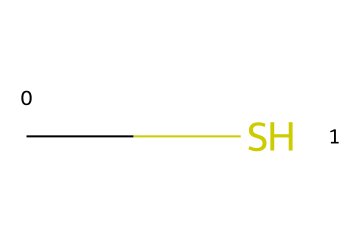What is the name of this compound? The structure represented by the SMILES designation "CS" corresponds to methylmercaptan, which is a sulfur compound. The 'C' represents a carbon atom, and the 'S' represents a sulfur atom, indicating the chemical name based on common nomenclature.
Answer: methylmercaptan How many atoms are present in this molecule? The SMILES notation "CS" indicates that there are two atoms in total: one carbon (C) and one sulfur (S) atom. The count can be determined by identifying each character in the SMILES string.
Answer: 2 What type of bond is present between the carbon and sulfur in this compound? In the structure represented by "CS", there is a single bond connecting the carbon atom to the sulfur atom. The absence of any double or triple bond notations in the SMILES indicates it is a single bond.
Answer: single bond What is the primary use of methylmercaptan? Methylmercaptan is primarily used for odorization of natural gas to provide a distinct smell, assisting in the detection of gas leaks, which is crucial for safety awareness among musicians touring with gas-powered equipment.
Answer: odorization of natural gas Is methylmercaptan a polar or nonpolar molecule? Methylmercaptan possesses a polar bond due to the difference in electronegativity between the carbon and sulfur atoms. The presence of the sulfur atom, which is more electronegative, creates a dipole moment, indicating polarity.
Answer: polar What does the presence of sulfur in this compound suggest about its odor? The inclusion of sulfur in methylmercaptan suggests it has a strong, unpleasant odor, often likened to rotten eggs or cabbage. This is characteristic of many sulfur-containing compounds, which are known for their pungent smells.
Answer: strong odor 